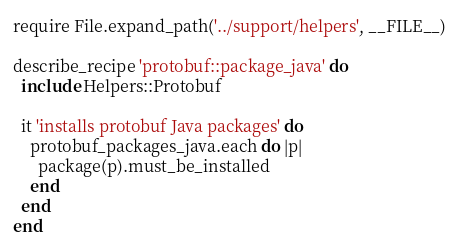<code> <loc_0><loc_0><loc_500><loc_500><_Ruby_>require File.expand_path('../support/helpers', __FILE__)

describe_recipe 'protobuf::package_java' do
  include Helpers::Protobuf

  it 'installs protobuf Java packages' do
    protobuf_packages_java.each do |p|
      package(p).must_be_installed
    end
  end
end
</code> 